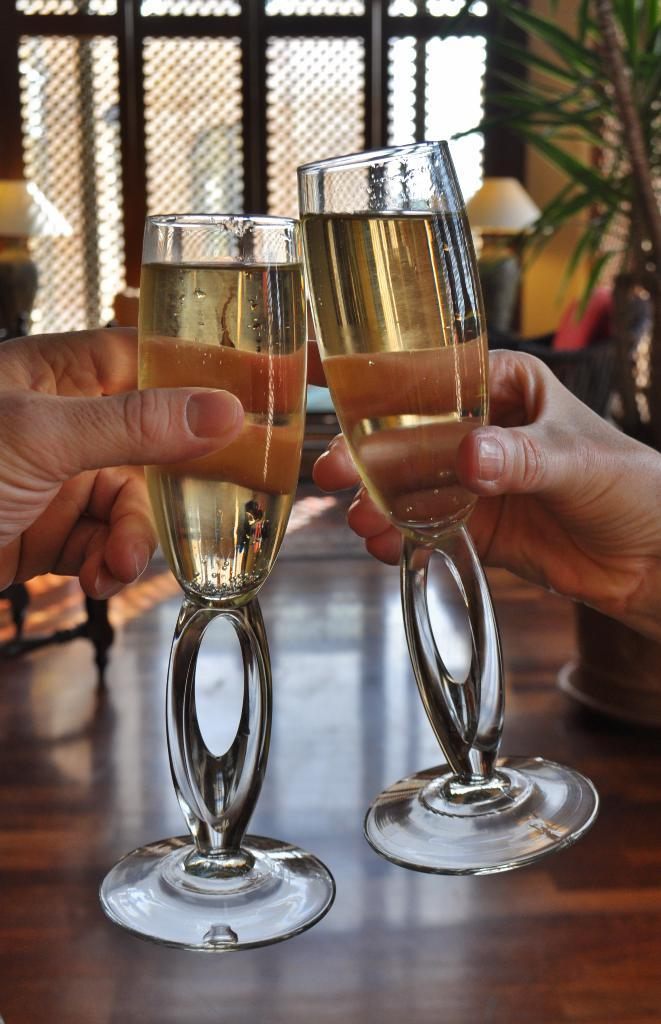What objects are being held by the hands in the image? There are two hands holding two glasses in the image. What can be seen in the background of the image? There are lamps, plants, windows, and a wall visible in the background of the image. What type of surface is visible in the image? There is a floor visible in the image. What type of legal advice is the lawyer providing in the image? There is no lawyer present in the image, so it is not possible to determine what type of legal advice might be provided. 